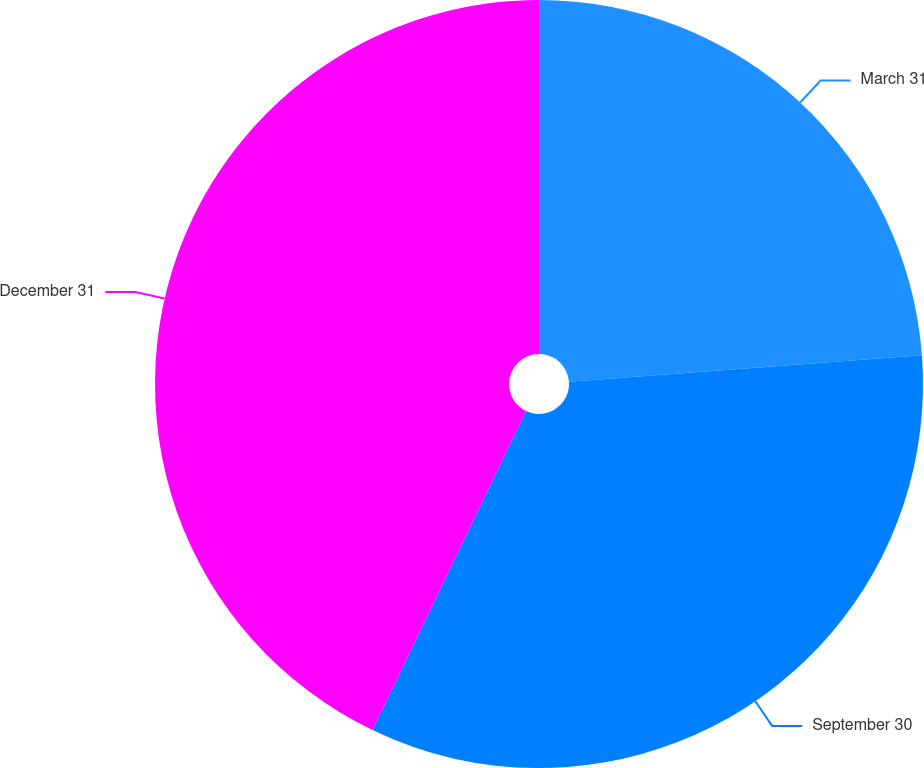Convert chart. <chart><loc_0><loc_0><loc_500><loc_500><pie_chart><fcel>March 31<fcel>September 30<fcel>December 31<nl><fcel>23.81%<fcel>33.33%<fcel>42.86%<nl></chart> 